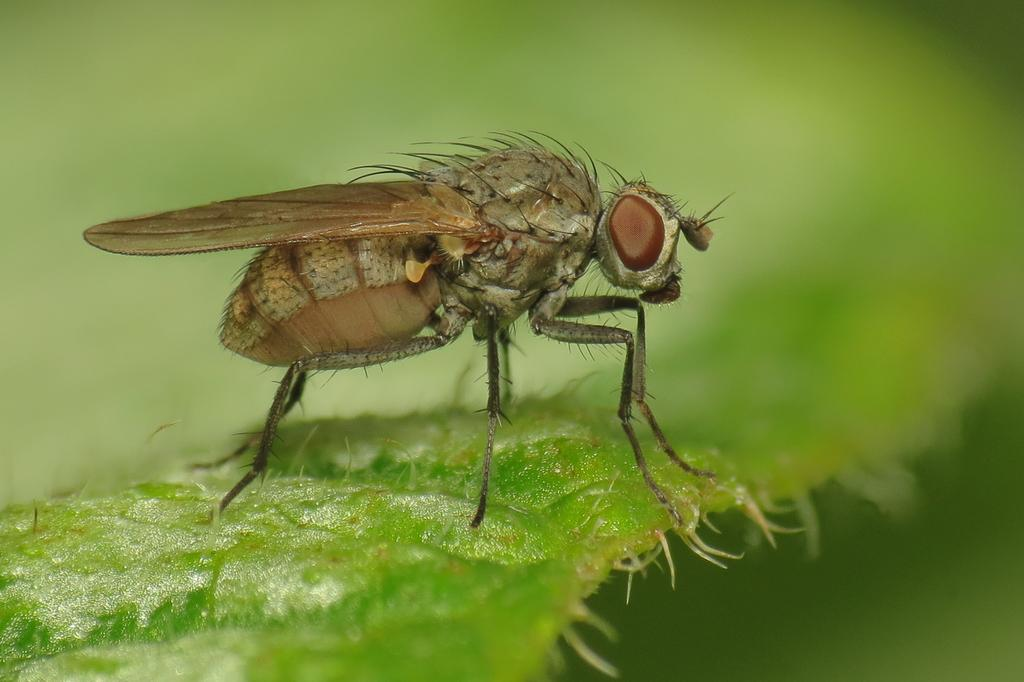What is present in the image? There is an insect in the image. Where is the insect located? The insect is sitting on a leaf. What flavor of ice cream is the insect holding in the image? There is no ice cream present in the image, and the insect is not holding anything. 